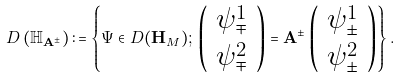<formula> <loc_0><loc_0><loc_500><loc_500>D \left ( \mathbb { H } _ { \mathbf A ^ { \pm } } \right ) \colon = \left \{ \Psi \in D ( \mathbf H _ { M } ) ; \, \left ( \begin{array} { c } \psi _ { \mp } ^ { 1 } \\ \psi _ { \mp } ^ { 2 } \end{array} \right ) = \mathbf A ^ { \pm } \left ( \begin{array} { c } \psi _ { \pm } ^ { 1 } \\ \psi _ { \pm } ^ { 2 } \end{array} \right ) \right \} .</formula> 